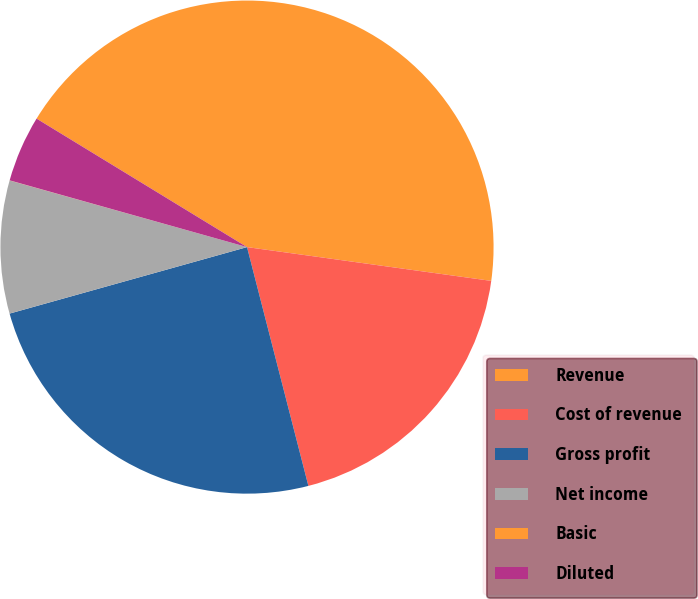<chart> <loc_0><loc_0><loc_500><loc_500><pie_chart><fcel>Revenue<fcel>Cost of revenue<fcel>Gross profit<fcel>Net income<fcel>Basic<fcel>Diluted<nl><fcel>43.47%<fcel>18.81%<fcel>24.66%<fcel>8.7%<fcel>0.01%<fcel>4.36%<nl></chart> 